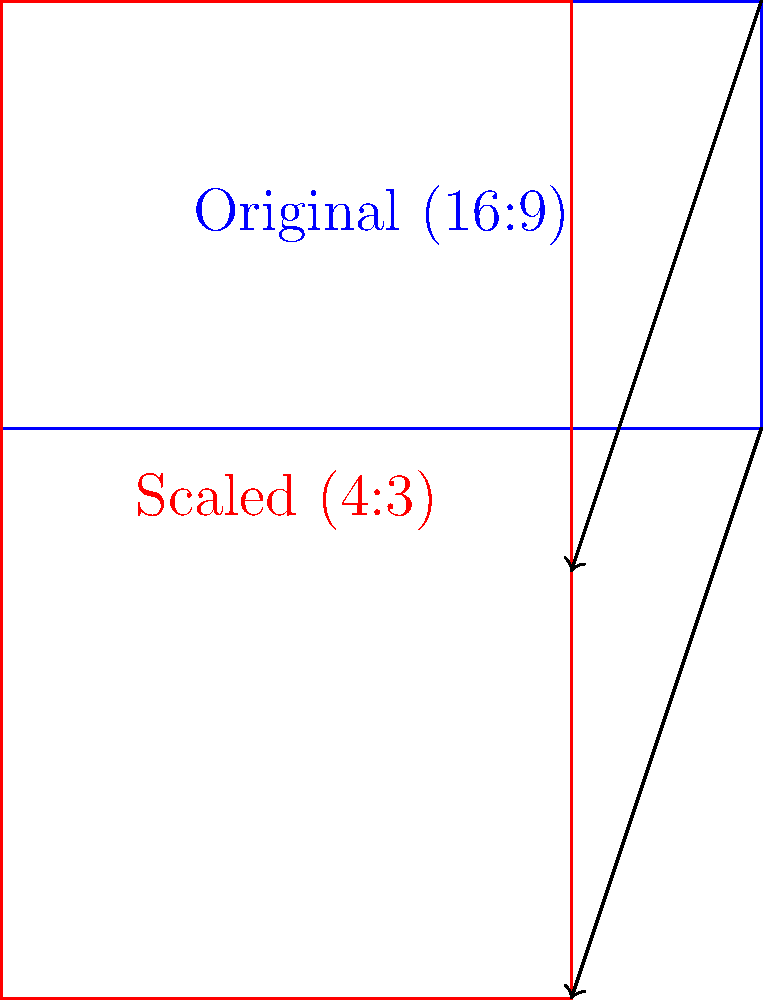As a cinematographer, you're adapting a storyboard sketch from a 16:9 aspect ratio to a 4:3 aspect ratio for a special screening. If the original sketch has a width of 16 units, what is the width of the scaled version to maintain the same height while fitting the new aspect ratio? To solve this problem, we'll follow these steps:

1) The original sketch has an aspect ratio of 16:9. Let's call the original width $w_1 = 16$ and the original height $h_1 = 9$.

2) We want to maintain the same height in the new 4:3 aspect ratio. So, the new height $h_2 = h_1 = 9$.

3) In the new 4:3 aspect ratio, we can set up the following equation:
   
   $\frac{w_2}{h_2} = \frac{4}{3}$

   Where $w_2$ is the new width we're trying to find.

4) Substituting the known values:

   $\frac{w_2}{9} = \frac{4}{3}$

5) Cross multiply:

   $3w_2 = 4 * 9$

6) Solve for $w_2$:

   $w_2 = \frac{4 * 9}{3} = 12$

Therefore, to maintain the same height and fit the 4:3 aspect ratio, the width of the scaled version should be 12 units.
Answer: 12 units 